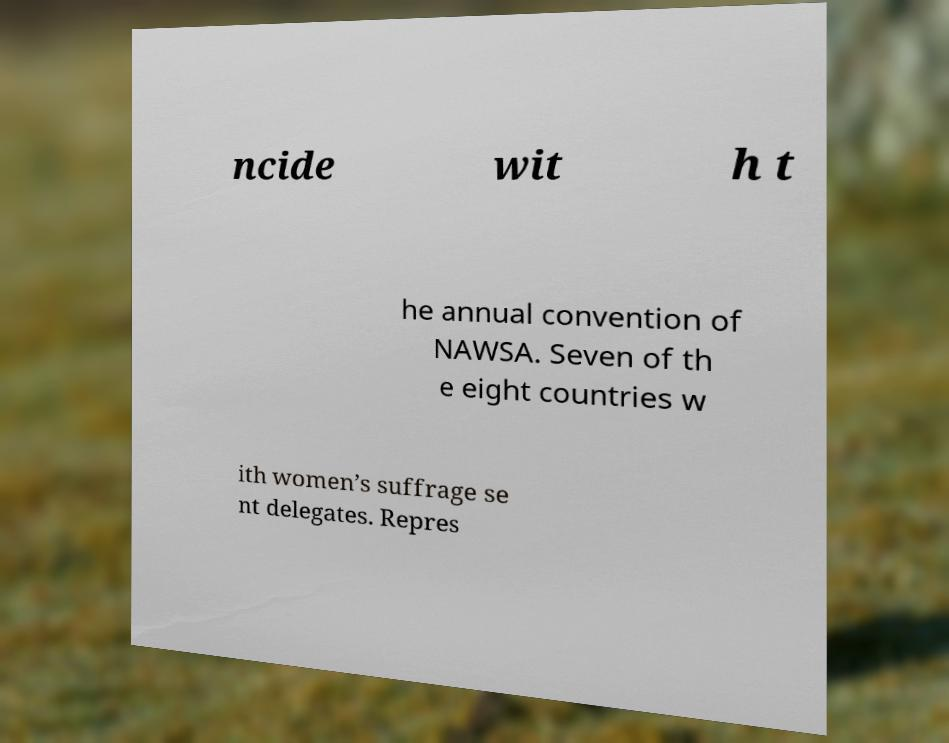Could you assist in decoding the text presented in this image and type it out clearly? ncide wit h t he annual convention of NAWSA. Seven of th e eight countries w ith women’s suffrage se nt delegates. Repres 